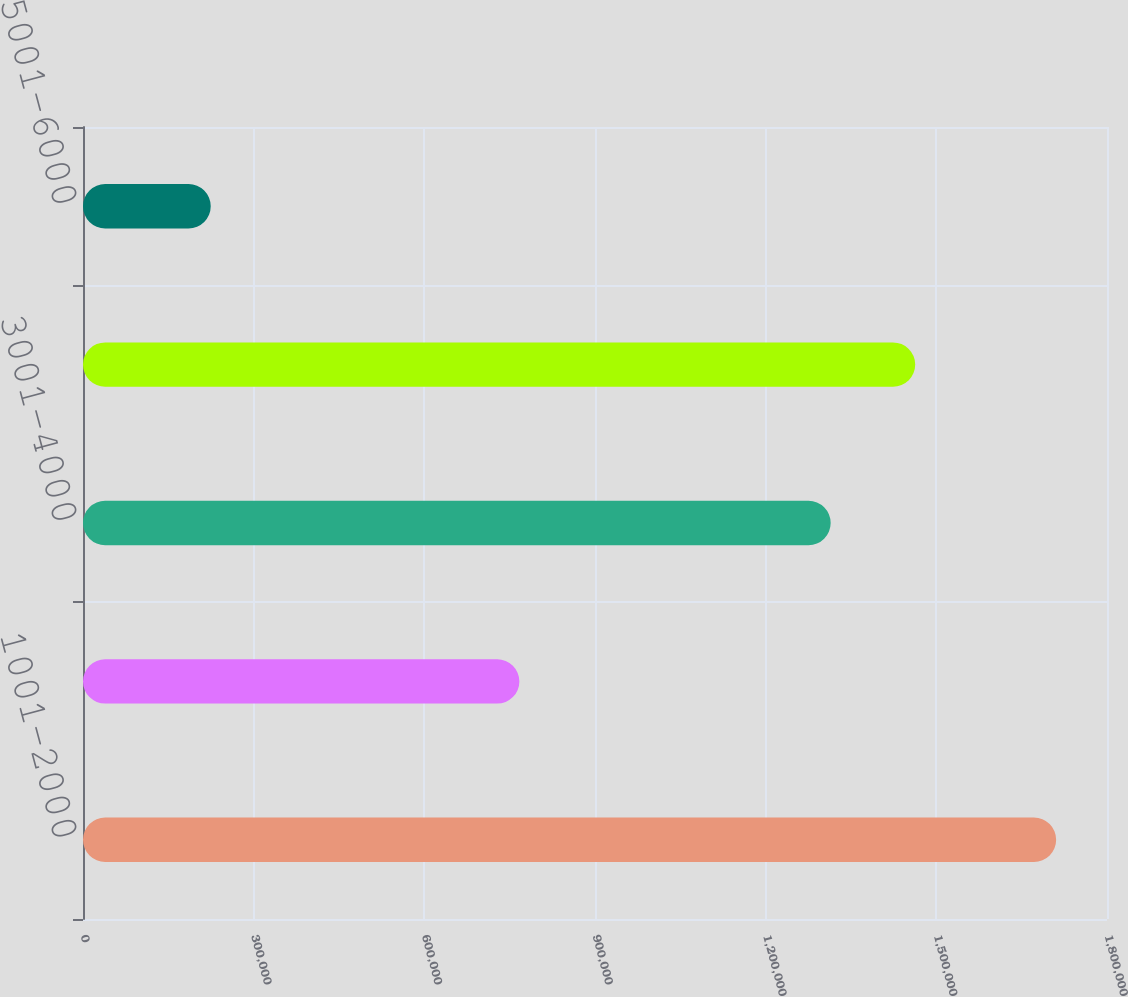Convert chart to OTSL. <chart><loc_0><loc_0><loc_500><loc_500><bar_chart><fcel>1001-2000<fcel>2001-3000<fcel>3001-4000<fcel>4001-5000<fcel>5001-6000<nl><fcel>1.7106e+06<fcel>767050<fcel>1.31424e+06<fcel>1.46286e+06<fcel>224500<nl></chart> 